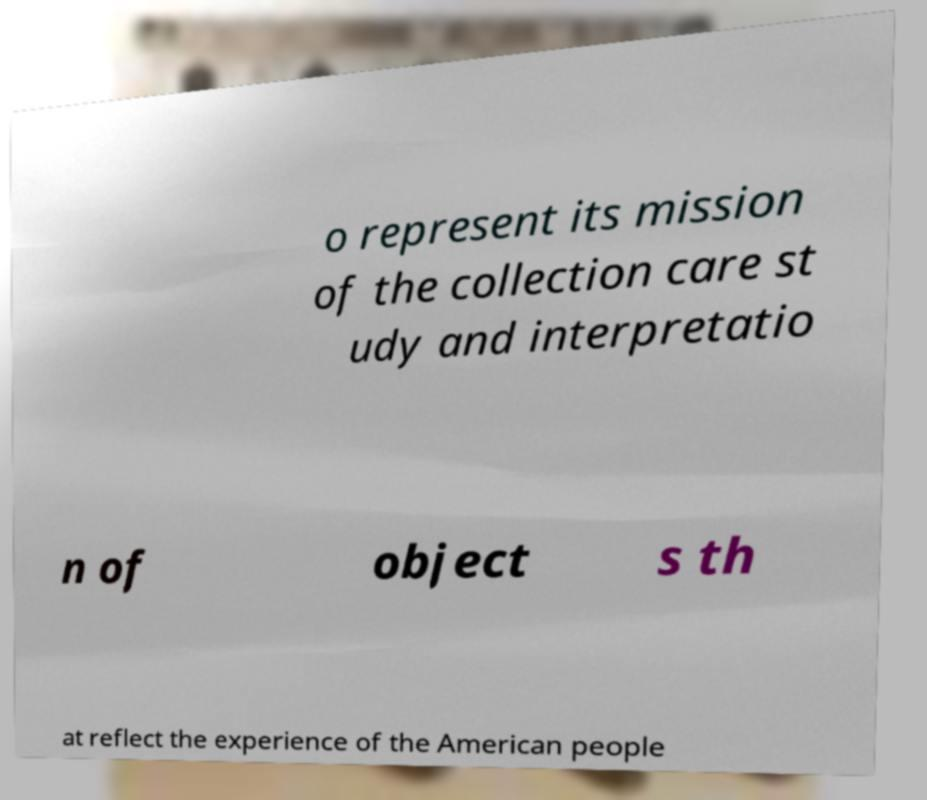Could you assist in decoding the text presented in this image and type it out clearly? o represent its mission of the collection care st udy and interpretatio n of object s th at reflect the experience of the American people 